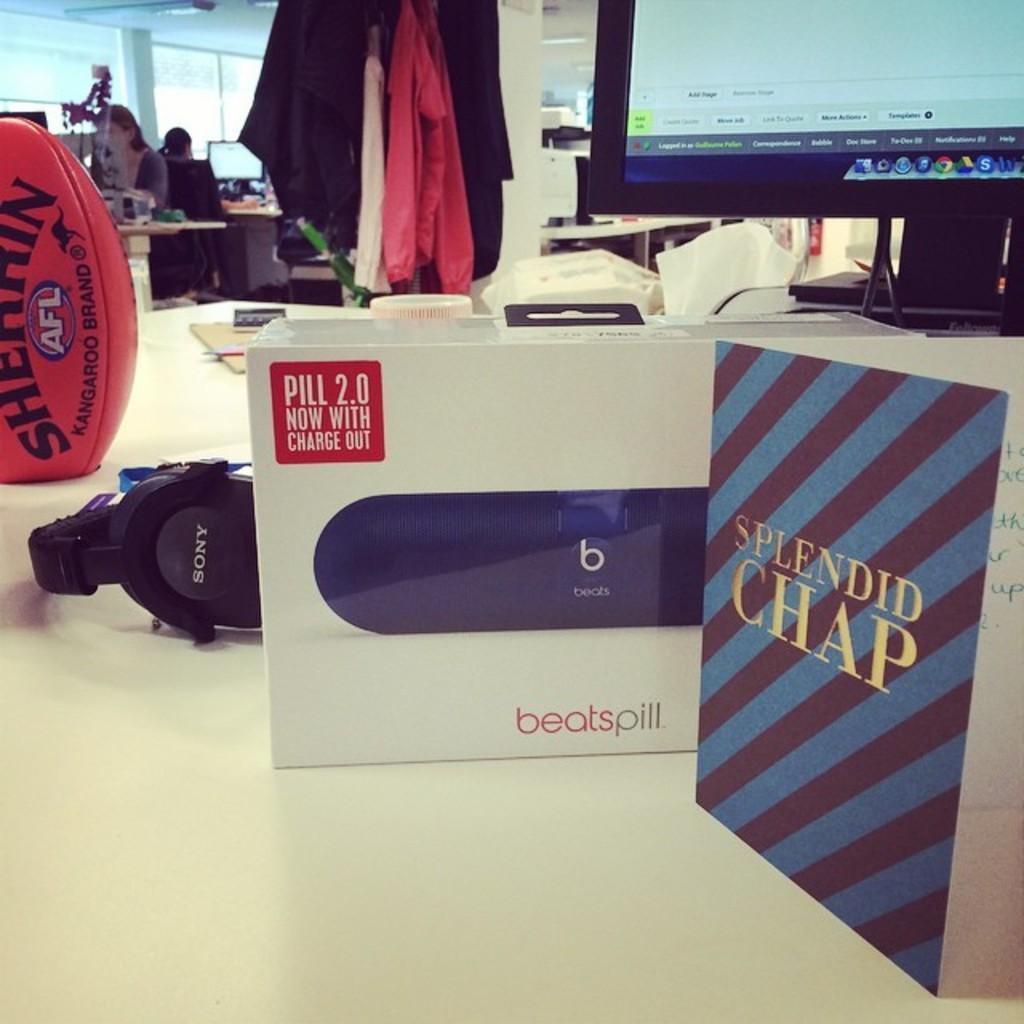How would you summarize this image in a sentence or two? In this image we can see a monitor, papers, box, headset and a ball which are placed on the table. On the backside we can see some clothes, a wall and a group of people sitting beside the monitors. 